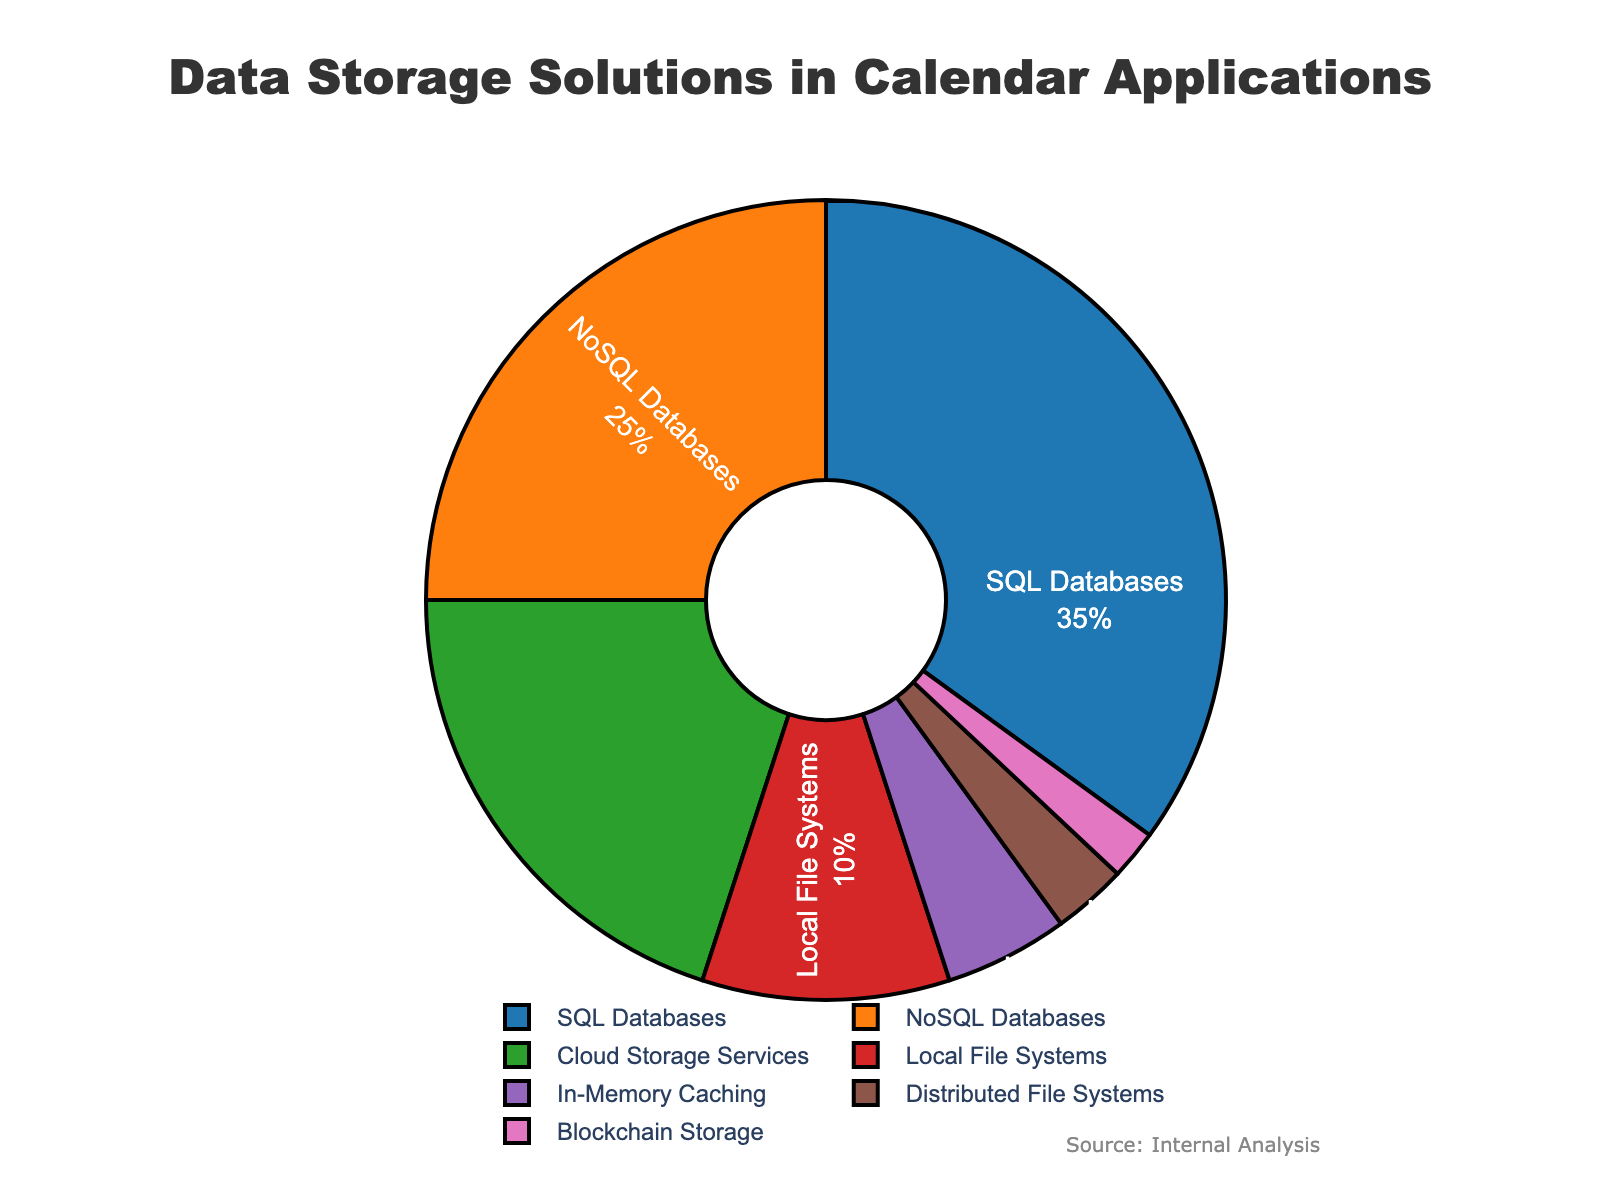Which type of data storage solution is used the most in calendar applications? The pie chart shows that SQL Databases occupy the largest section, which indicates they are the most used data storage solution.
Answer: SQL Databases What is the combined percentage of NoSQL Databases and Cloud Storage Services? Add the percentages of NoSQL Databases (25%) and Cloud Storage Services (20%) to find the combined total.
Answer: 45% How much more popular are SQL Databases compared to In-Memory Caching? Subtract the percentage of In-Memory Caching (5%) from the percentage of SQL Databases (35%).
Answer: 30% Which is the least used data storage solution? The smallest section of the pie chart belongs to Blockchain Storage, indicating it is the least used solution at 2%.
Answer: Blockchain Storage What is the difference in usage percentage between Local File Systems and Distributed File Systems? Subtract the percentage of Distributed File Systems (3%) from Local File Systems (10%).
Answer: 7% Which storage solutions together account for more than 50% of the usage? Adding the percentages of the top three storage solutions: SQL Databases (35%), NoSQL Databases (25%), and Cloud Storage Services (20%) gives a total of 80%, which is more than 50%.
Answer: SQL Databases, NoSQL Databases, Cloud Storage Services How many data storage solutions account for less than 15% of the total combined? Add the percentages of Local File Systems (10%), In-Memory Caching (5%), Distributed File Systems (3%), and Blockchain Storage (2%) to see if they are less than 15%. The sum is 20%, therefore, each of these four solutions individually accounts for less than 15%.
Answer: Four Is Cloud Storage Services usage greater or less than NoSQL Databases? Compare the respective percentages: Cloud Storage Services (20%) is less than NoSQL Databases (25%).
Answer: Less Which color represents Local File Systems in the pie chart? The pie chart uses a distinct color for each section, and Local File Systems are represented by the color red.
Answer: Red 